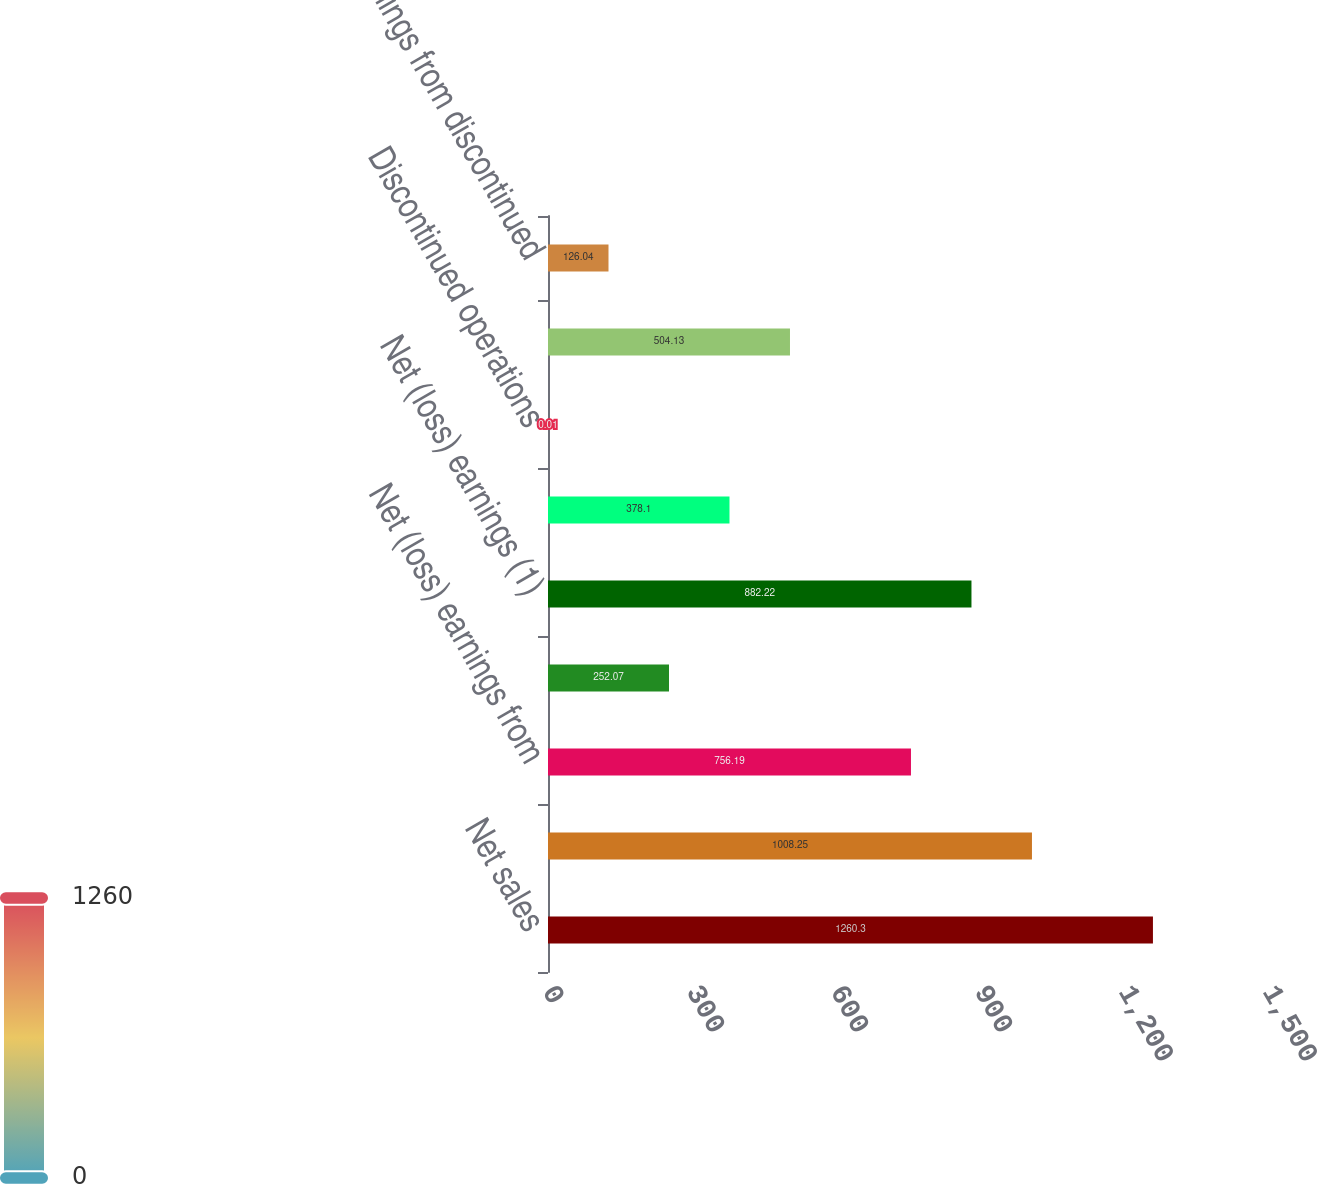<chart> <loc_0><loc_0><loc_500><loc_500><bar_chart><fcel>Net sales<fcel>Gross profit<fcel>Net (loss) earnings from<fcel>Gain on sale of discontinued<fcel>Net (loss) earnings (1)<fcel>Continuing operations<fcel>Discontinued operations<fcel>Net (loss) earnings per common<fcel>Net earnings from discontinued<nl><fcel>1260.3<fcel>1008.25<fcel>756.19<fcel>252.07<fcel>882.22<fcel>378.1<fcel>0.01<fcel>504.13<fcel>126.04<nl></chart> 